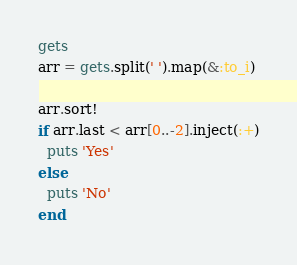<code> <loc_0><loc_0><loc_500><loc_500><_Ruby_>gets
arr = gets.split(' ').map(&:to_i)

arr.sort!
if arr.last < arr[0..-2].inject(:+)
  puts 'Yes'
else
  puts 'No'
end</code> 